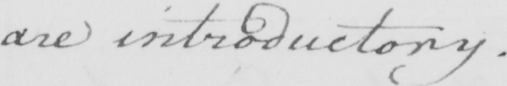Transcribe the text shown in this historical manuscript line. are introductory. 